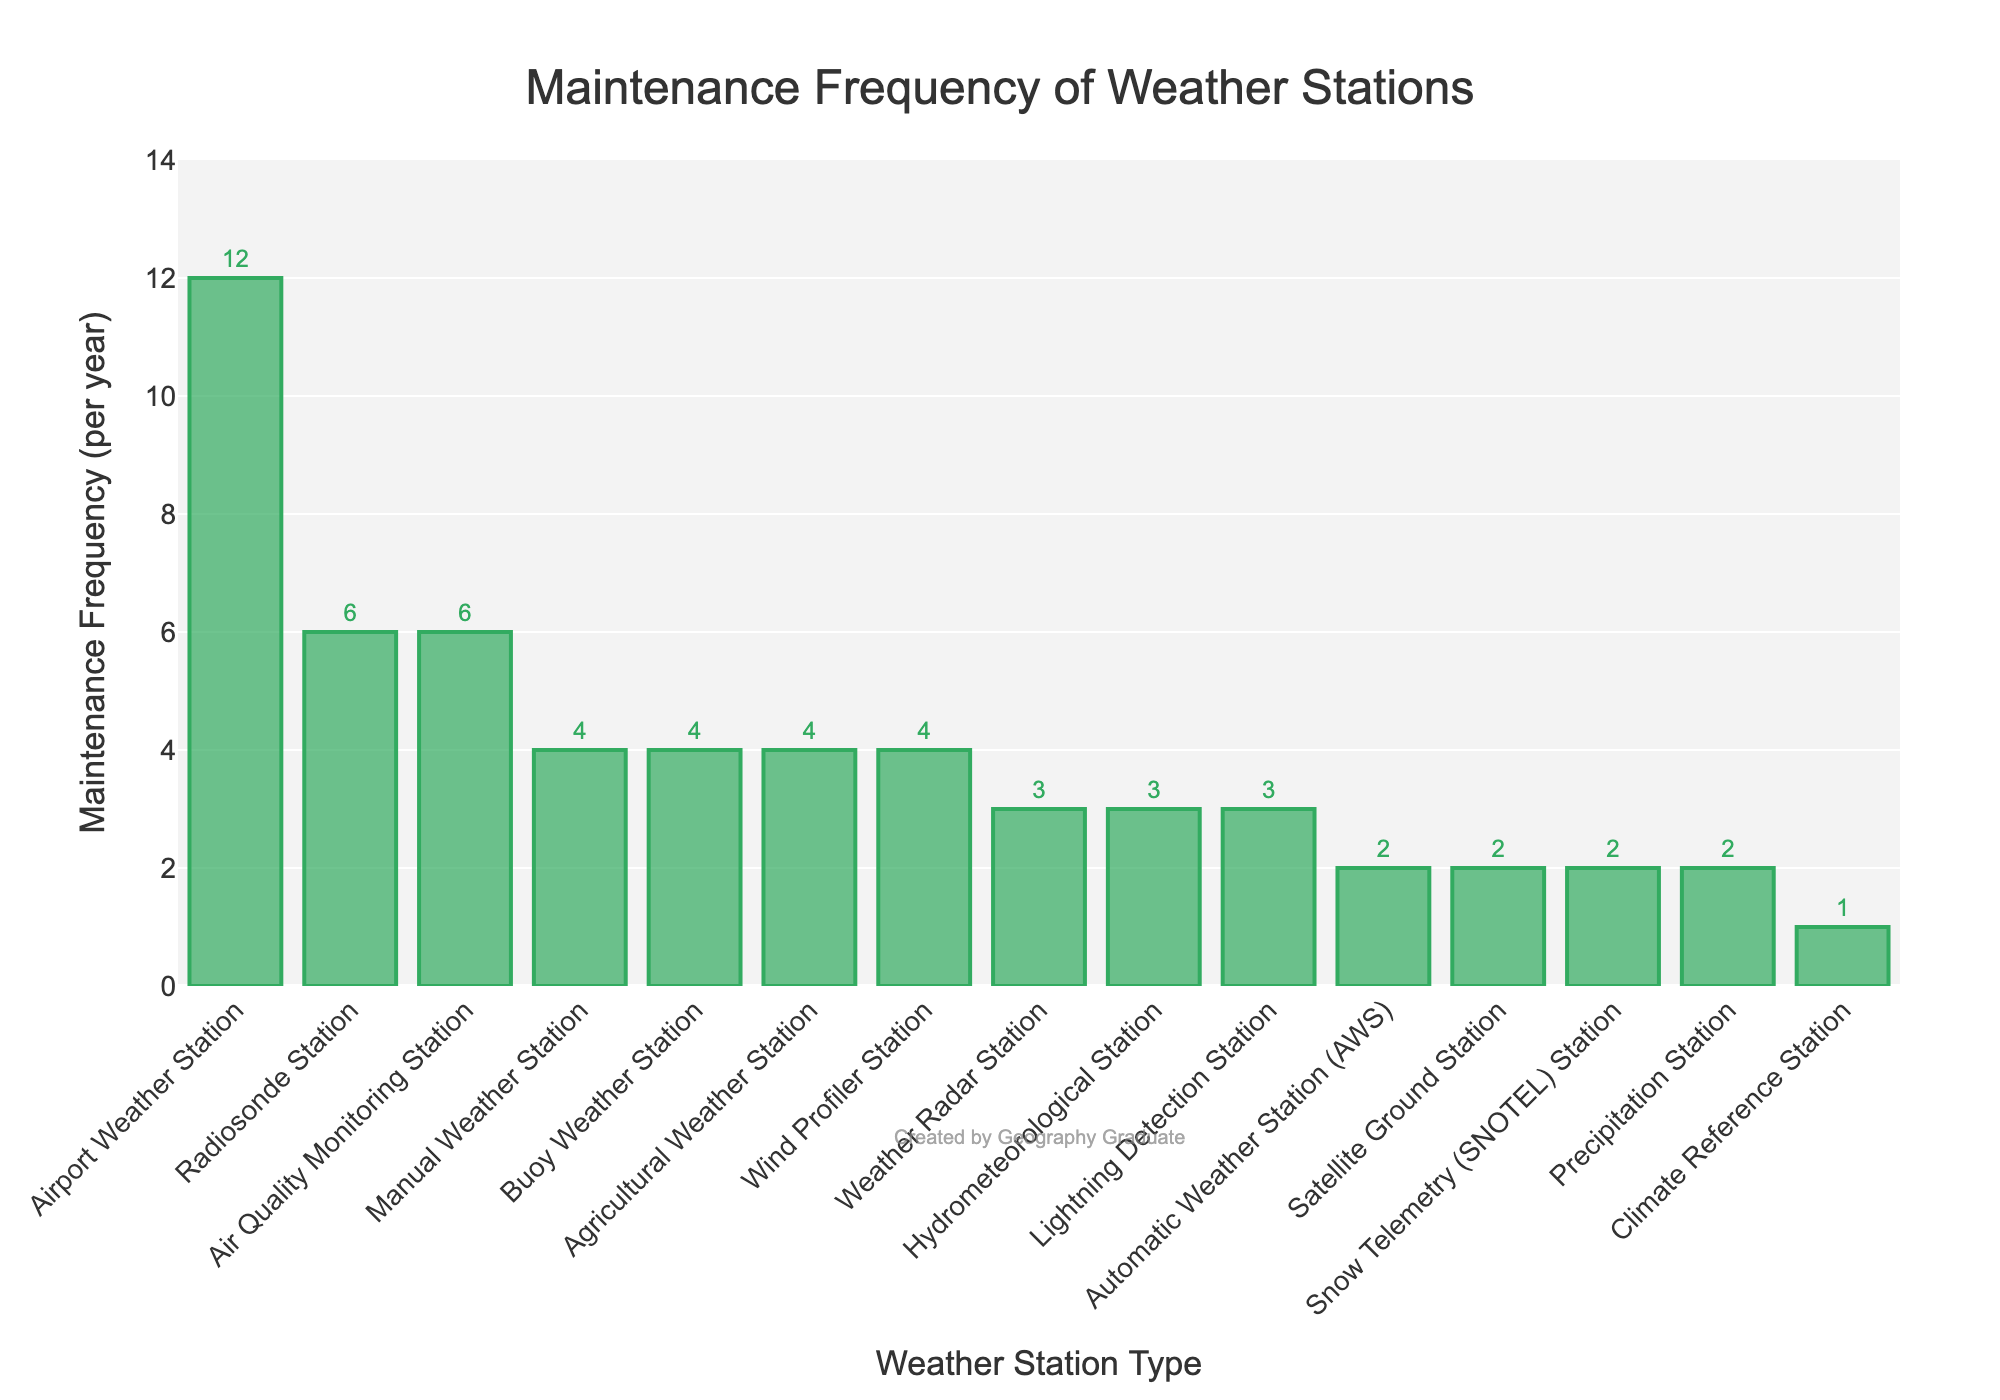Which weather station type requires the most frequent maintenance? The figure shows various types of weather stations and their maintenance frequencies per year. The bar for the airport weather station is the tallest, indicating it has the highest maintenance frequency.
Answer: Airport Weather Station Which two types of weather stations have the same maintenance frequency and what is that frequency? By examining the heights of the bars and their associated labels, we see that the Automatic Weather Station (AWS), Satellite Ground Station, Snow Telemetry (SNOTEL) Station, and Precipitation Station all share the same shorter bar height corresponding to the frequency of 2.
Answer: 2 What is the total maintenance frequency for the Agriculture Weather Station, Manual Weather Station, and Buoy Weather Station combined? Sum the maintenance frequencies: Agriculture Weather Station (4) + Manual Weather Station (4) + Buoy Weather Station (4). 4 + 4 + 4 = 12.
Answer: 12 List the weather station types that require less maintenance frequency than Weather Radar Station. The Weather Radar Station has a maintenance frequency of 3. Stations with a frequency less than 3 are Automatic Weather Station (2), Satellite Ground Station (2), Climate Reference Station (1), Snow Telemetry (SNOTEL) Station (2), and Precipitation Station (2).
Answer: Automatic Weather Station, Satellite Ground Station, Climate Reference Station, Snow Telemetry (SNOTEL) Station, Precipitation Station What is the difference in maintenance frequency between the station that requires the most and the station that requires the least maintenance? Subtract the lowest frequency (Climate Reference Station, 1) from the highest frequency (Airport Weather Station, 12). 12 - 1 = 11.
Answer: 11 What percentage of stations have a maintenance frequency equal to or greater than 4? Count the stations with frequency >= 4: Manual Weather Station, Radiosonde Station, Buoy Weather Station, Airport Weather Station, Agricultural Weather Station, Air Quality Monitoring Station, Wind Profiler Station. This is 7 stations out of 15 total stations. Calculate 7/15*100 to get the percentage. 7/15 ≈ 0.467, and 0.467*100 ≈ 46.7%.
Answer: 46.7% How many types of weather stations require maintenance exactly 3 times per year? Count the bars with height corresponding to the frequency of 3: Weather Radar Station, Hydrometeorological Station, Lightning Detection Station. There are 3 such stations.
Answer: 3 What is the average maintenance frequency for all weather station types shown? Sum all maintenance frequencies and divide by the number of station types. (2+4+6+3+2+4+12+3+4+1+2+3+6+2+4)/15 = 58/15 ≈ 3.87.
Answer: 3.87 